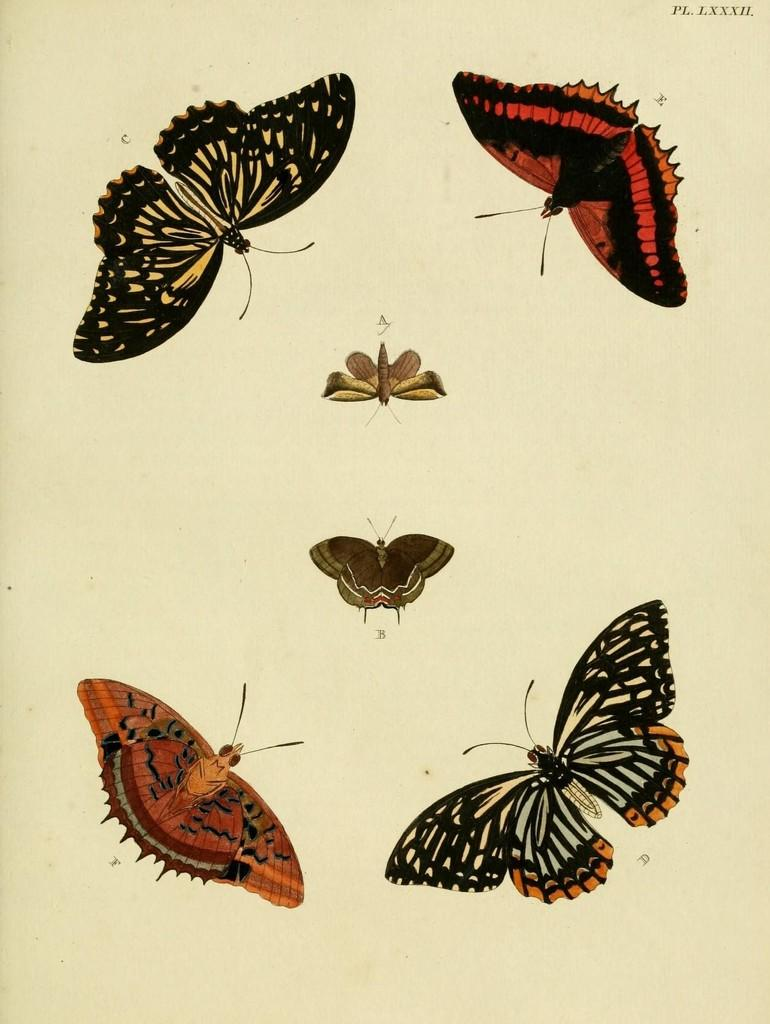What type of animals can be seen in the image? There are butterflies in the image. What can be observed about the butterflies in terms of their appearance? The butterflies are in different colors. What is the color of the background in the image? The background of the image is cream-colored. Is there any text present in the image? Yes, there is text written on the background. How does the butterflies' profit increase in the image? There is no mention of profit or increase in the image; it features butterflies in different colors with text on a cream-colored background. 